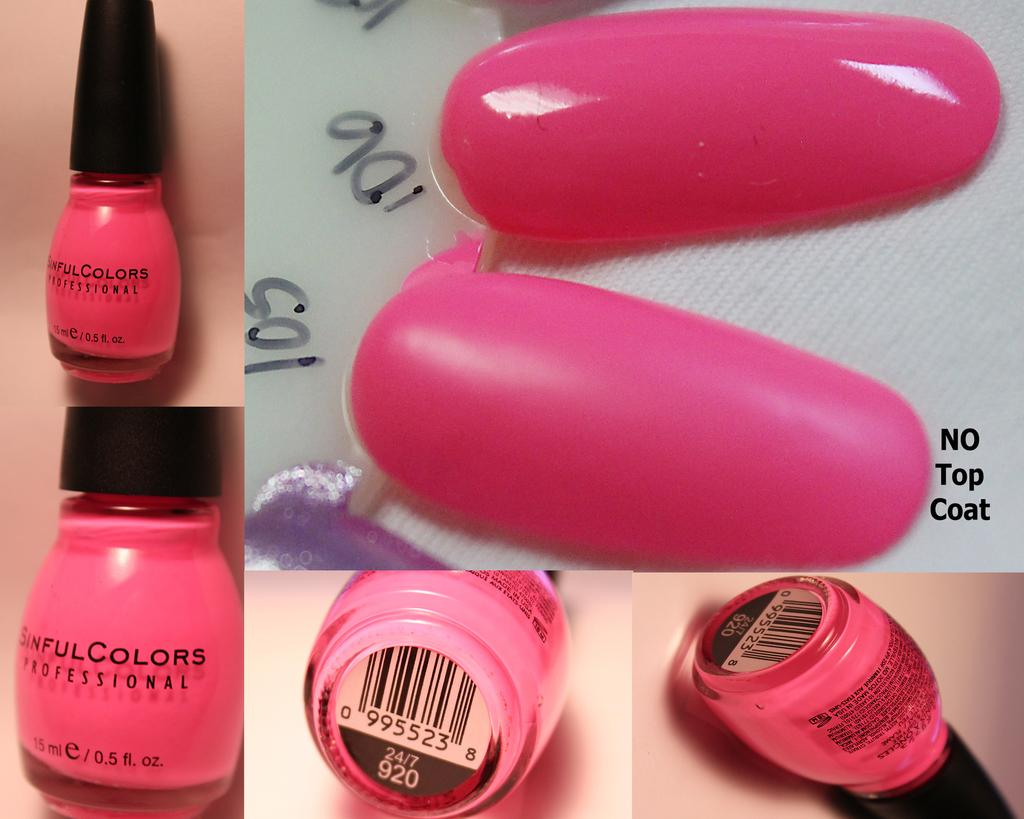<image>
Share a concise interpretation of the image provided. Several angles of hot pink sinful colors branded nail polish 